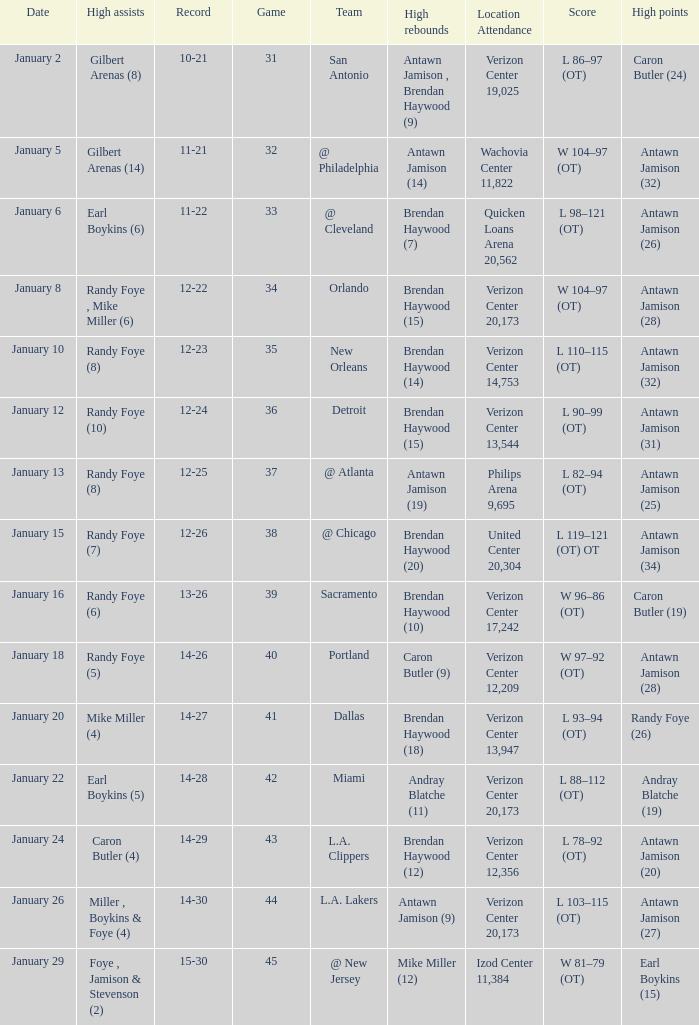Parse the full table. {'header': ['Date', 'High assists', 'Record', 'Game', 'Team', 'High rebounds', 'Location Attendance', 'Score', 'High points'], 'rows': [['January 2', 'Gilbert Arenas (8)', '10-21', '31', 'San Antonio', 'Antawn Jamison , Brendan Haywood (9)', 'Verizon Center 19,025', 'L 86–97 (OT)', 'Caron Butler (24)'], ['January 5', 'Gilbert Arenas (14)', '11-21', '32', '@ Philadelphia', 'Antawn Jamison (14)', 'Wachovia Center 11,822', 'W 104–97 (OT)', 'Antawn Jamison (32)'], ['January 6', 'Earl Boykins (6)', '11-22', '33', '@ Cleveland', 'Brendan Haywood (7)', 'Quicken Loans Arena 20,562', 'L 98–121 (OT)', 'Antawn Jamison (26)'], ['January 8', 'Randy Foye , Mike Miller (6)', '12-22', '34', 'Orlando', 'Brendan Haywood (15)', 'Verizon Center 20,173', 'W 104–97 (OT)', 'Antawn Jamison (28)'], ['January 10', 'Randy Foye (8)', '12-23', '35', 'New Orleans', 'Brendan Haywood (14)', 'Verizon Center 14,753', 'L 110–115 (OT)', 'Antawn Jamison (32)'], ['January 12', 'Randy Foye (10)', '12-24', '36', 'Detroit', 'Brendan Haywood (15)', 'Verizon Center 13,544', 'L 90–99 (OT)', 'Antawn Jamison (31)'], ['January 13', 'Randy Foye (8)', '12-25', '37', '@ Atlanta', 'Antawn Jamison (19)', 'Philips Arena 9,695', 'L 82–94 (OT)', 'Antawn Jamison (25)'], ['January 15', 'Randy Foye (7)', '12-26', '38', '@ Chicago', 'Brendan Haywood (20)', 'United Center 20,304', 'L 119–121 (OT) OT', 'Antawn Jamison (34)'], ['January 16', 'Randy Foye (6)', '13-26', '39', 'Sacramento', 'Brendan Haywood (10)', 'Verizon Center 17,242', 'W 96–86 (OT)', 'Caron Butler (19)'], ['January 18', 'Randy Foye (5)', '14-26', '40', 'Portland', 'Caron Butler (9)', 'Verizon Center 12,209', 'W 97–92 (OT)', 'Antawn Jamison (28)'], ['January 20', 'Mike Miller (4)', '14-27', '41', 'Dallas', 'Brendan Haywood (18)', 'Verizon Center 13,947', 'L 93–94 (OT)', 'Randy Foye (26)'], ['January 22', 'Earl Boykins (5)', '14-28', '42', 'Miami', 'Andray Blatche (11)', 'Verizon Center 20,173', 'L 88–112 (OT)', 'Andray Blatche (19)'], ['January 24', 'Caron Butler (4)', '14-29', '43', 'L.A. Clippers', 'Brendan Haywood (12)', 'Verizon Center 12,356', 'L 78–92 (OT)', 'Antawn Jamison (20)'], ['January 26', 'Miller , Boykins & Foye (4)', '14-30', '44', 'L.A. Lakers', 'Antawn Jamison (9)', 'Verizon Center 20,173', 'L 103–115 (OT)', 'Antawn Jamison (27)'], ['January 29', 'Foye , Jamison & Stevenson (2)', '15-30', '45', '@ New Jersey', 'Mike Miller (12)', 'Izod Center 11,384', 'W 81–79 (OT)', 'Earl Boykins (15)']]} Who had the highest points on January 2? Caron Butler (24). 